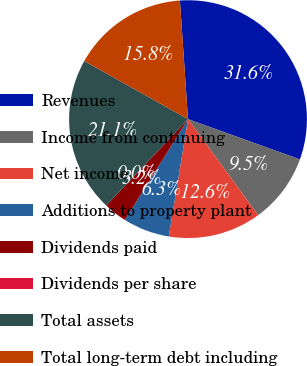Convert chart. <chart><loc_0><loc_0><loc_500><loc_500><pie_chart><fcel>Revenues<fcel>Income from continuing<fcel>Net income<fcel>Additions to property plant<fcel>Dividends paid<fcel>Dividends per share<fcel>Total assets<fcel>Total long-term debt including<nl><fcel>31.58%<fcel>9.47%<fcel>12.63%<fcel>6.32%<fcel>3.16%<fcel>0.0%<fcel>21.06%<fcel>15.79%<nl></chart> 